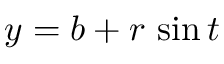<formula> <loc_0><loc_0><loc_500><loc_500>y = b + r \, \sin t \,</formula> 